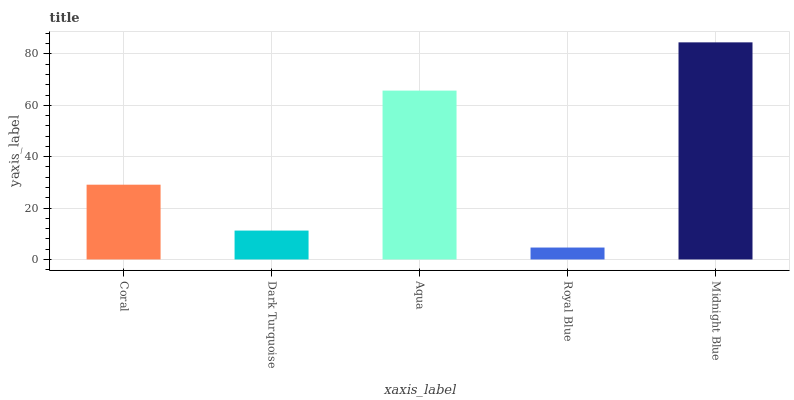Is Royal Blue the minimum?
Answer yes or no. Yes. Is Midnight Blue the maximum?
Answer yes or no. Yes. Is Dark Turquoise the minimum?
Answer yes or no. No. Is Dark Turquoise the maximum?
Answer yes or no. No. Is Coral greater than Dark Turquoise?
Answer yes or no. Yes. Is Dark Turquoise less than Coral?
Answer yes or no. Yes. Is Dark Turquoise greater than Coral?
Answer yes or no. No. Is Coral less than Dark Turquoise?
Answer yes or no. No. Is Coral the high median?
Answer yes or no. Yes. Is Coral the low median?
Answer yes or no. Yes. Is Aqua the high median?
Answer yes or no. No. Is Royal Blue the low median?
Answer yes or no. No. 